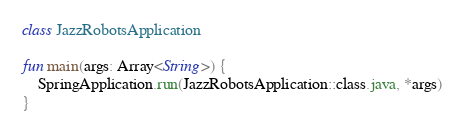Convert code to text. <code><loc_0><loc_0><loc_500><loc_500><_Kotlin_>class JazzRobotsApplication

fun main(args: Array<String>) {
    SpringApplication.run(JazzRobotsApplication::class.java, *args)
}
</code> 